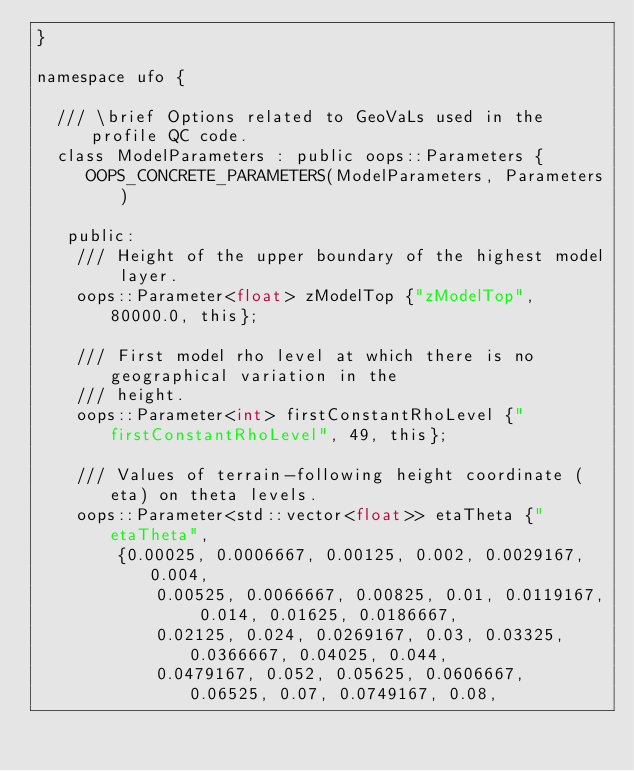Convert code to text. <code><loc_0><loc_0><loc_500><loc_500><_C_>}

namespace ufo {

  /// \brief Options related to GeoVaLs used in the profile QC code.
  class ModelParameters : public oops::Parameters {
     OOPS_CONCRETE_PARAMETERS(ModelParameters, Parameters)

   public:
    /// Height of the upper boundary of the highest model layer.
    oops::Parameter<float> zModelTop {"zModelTop", 80000.0, this};

    /// First model rho level at which there is no geographical variation in the
    /// height.
    oops::Parameter<int> firstConstantRhoLevel {"firstConstantRhoLevel", 49, this};

    /// Values of terrain-following height coordinate (eta) on theta levels.
    oops::Parameter<std::vector<float>> etaTheta {"etaTheta",
        {0.00025, 0.0006667, 0.00125, 0.002, 0.0029167, 0.004,
            0.00525, 0.0066667, 0.00825, 0.01, 0.0119167, 0.014, 0.01625, 0.0186667,
            0.02125, 0.024, 0.0269167, 0.03, 0.03325, 0.0366667, 0.04025, 0.044,
            0.0479167, 0.052, 0.05625, 0.0606667, 0.06525, 0.07, 0.0749167, 0.08,</code> 